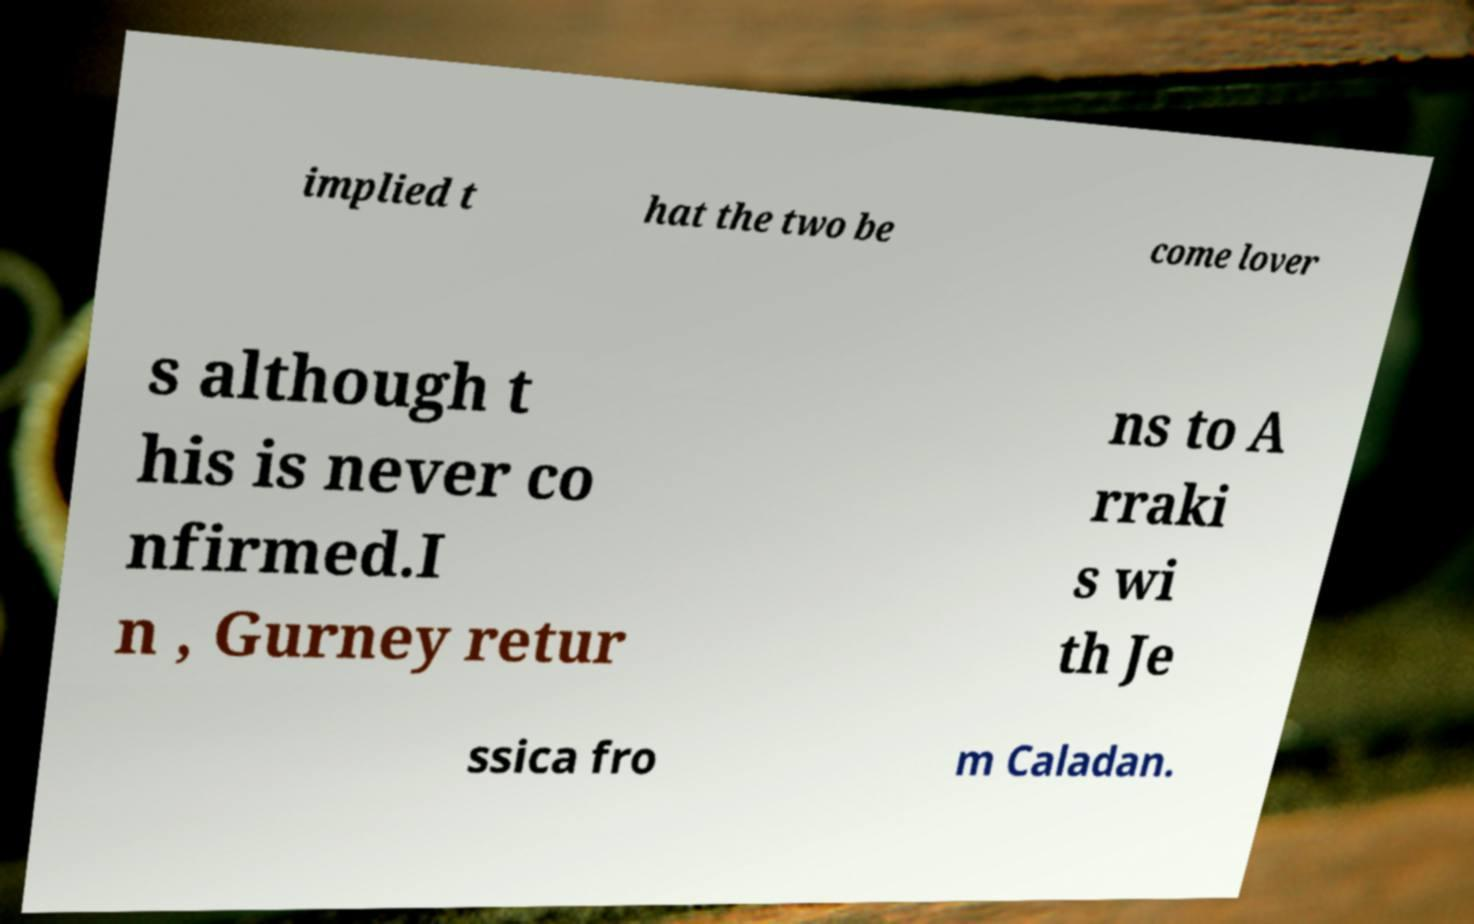Can you read and provide the text displayed in the image?This photo seems to have some interesting text. Can you extract and type it out for me? implied t hat the two be come lover s although t his is never co nfirmed.I n , Gurney retur ns to A rraki s wi th Je ssica fro m Caladan. 